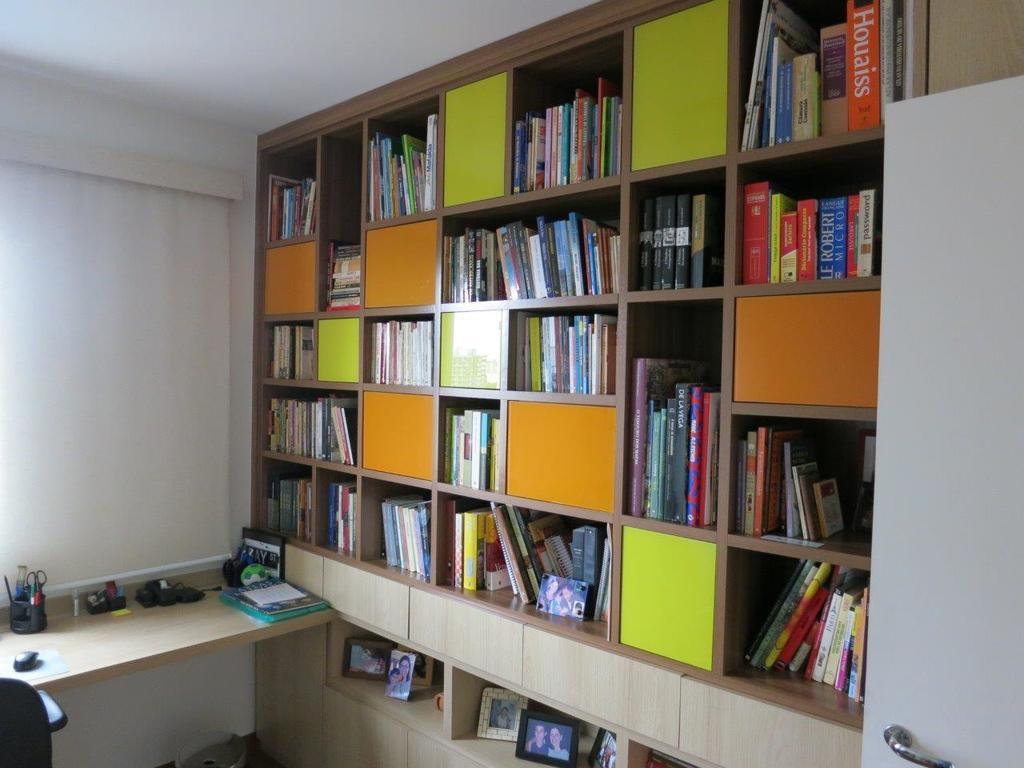<image>
Summarize the visual content of the image. A large bookcase with a big orange book called Houaiss. 